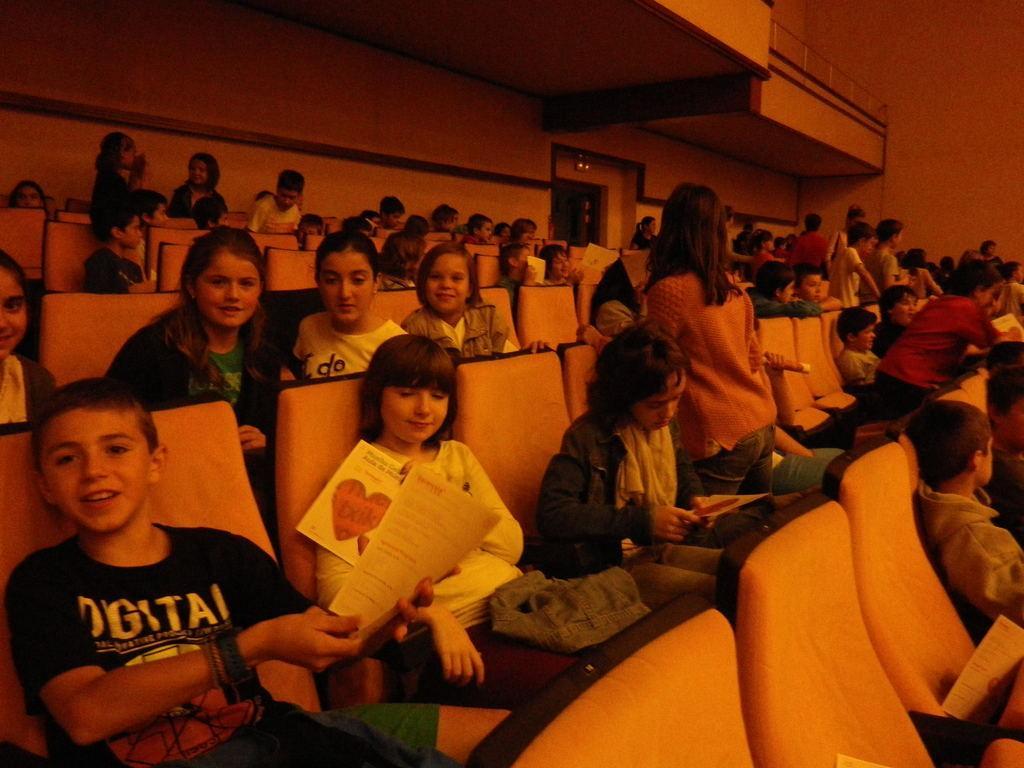In one or two sentences, can you explain what this image depicts? In this image we can see an auditorium. There are many people and few people holding some objects in their hands in the image. 